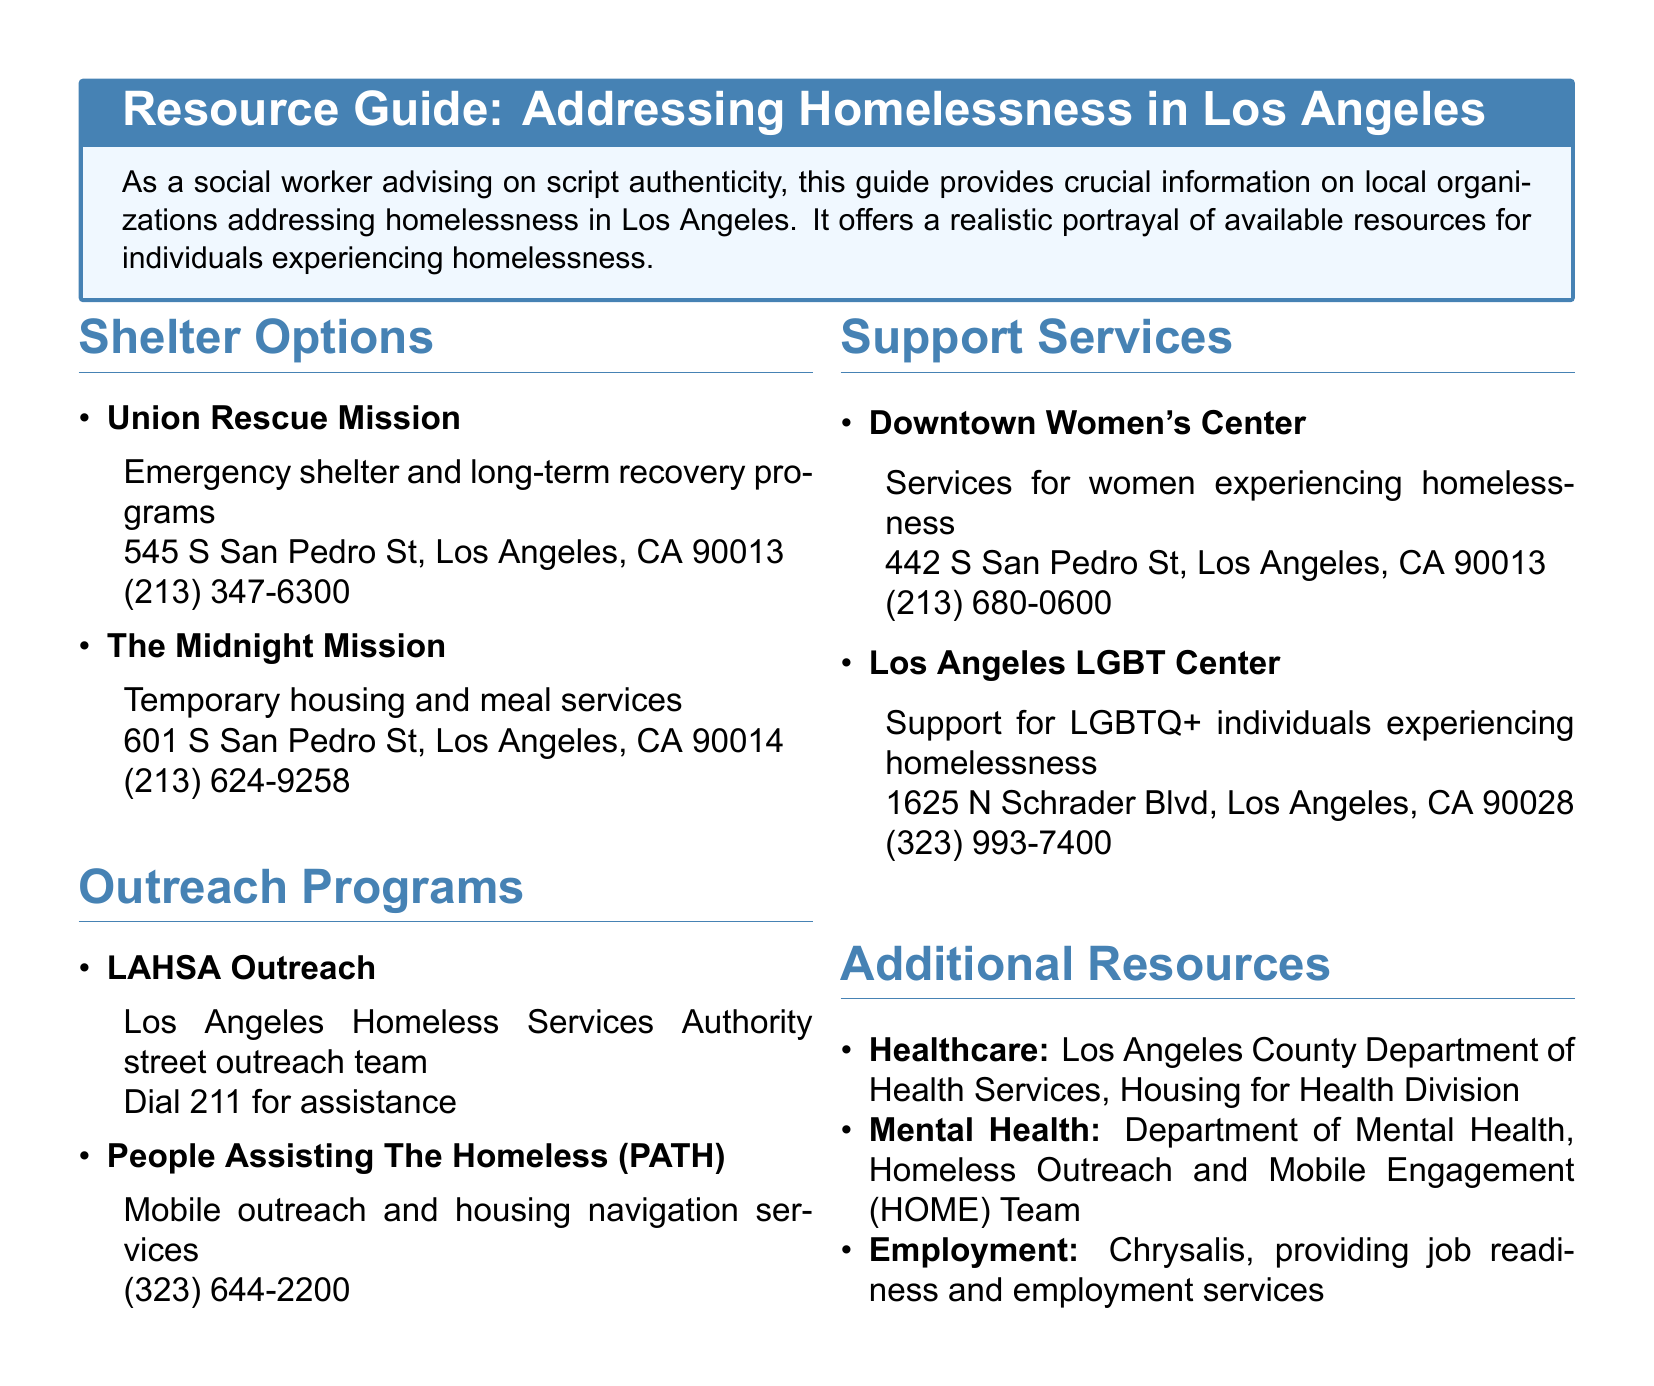What is the address of the Union Rescue Mission? The address can be found in the Shelter Options section of the document, which lists specific locations for each organization.
Answer: 545 S San Pedro St, Los Angeles, CA 90013 What type of services does The Midnight Mission provide? The Midnight Mission's services are outlined in the Shelter Options section, listing the specific services they offer.
Answer: Temporary housing and meal services What phone number should be dialed for LAHSA Outreach assistance? The contact information for LAHSA Outreach is provided in the Outreach Programs section, where the action to take for assistance is specified.
Answer: 211 Which organization offers services specifically for women experiencing homelessness? The document details various services, and the one specifically addressing women is found in the Support Services section.
Answer: Downtown Women's Center How many shelter options are listed in total? The total number of shelter options can be determined by counting the items in the Shelter Options section of the document.
Answer: 2 What is the main focus of the Los Angeles LGBT Center? The description of the Los Angeles LGBT Center in the Support Services section indicates its target demographic and service focus.
Answer: Support for LGBTQ+ individuals experiencing homelessness Which organization provides job readiness services? The Employment section mentions a specific organization that offers job readiness programs, allowing us to identify it clearly.
Answer: Chrysalis What type of division does the Los Angeles County Department of Health Services focus on? This information can be found in the Additional Resources section, which discusses the focus of this specific division.
Answer: Housing for Health Division 